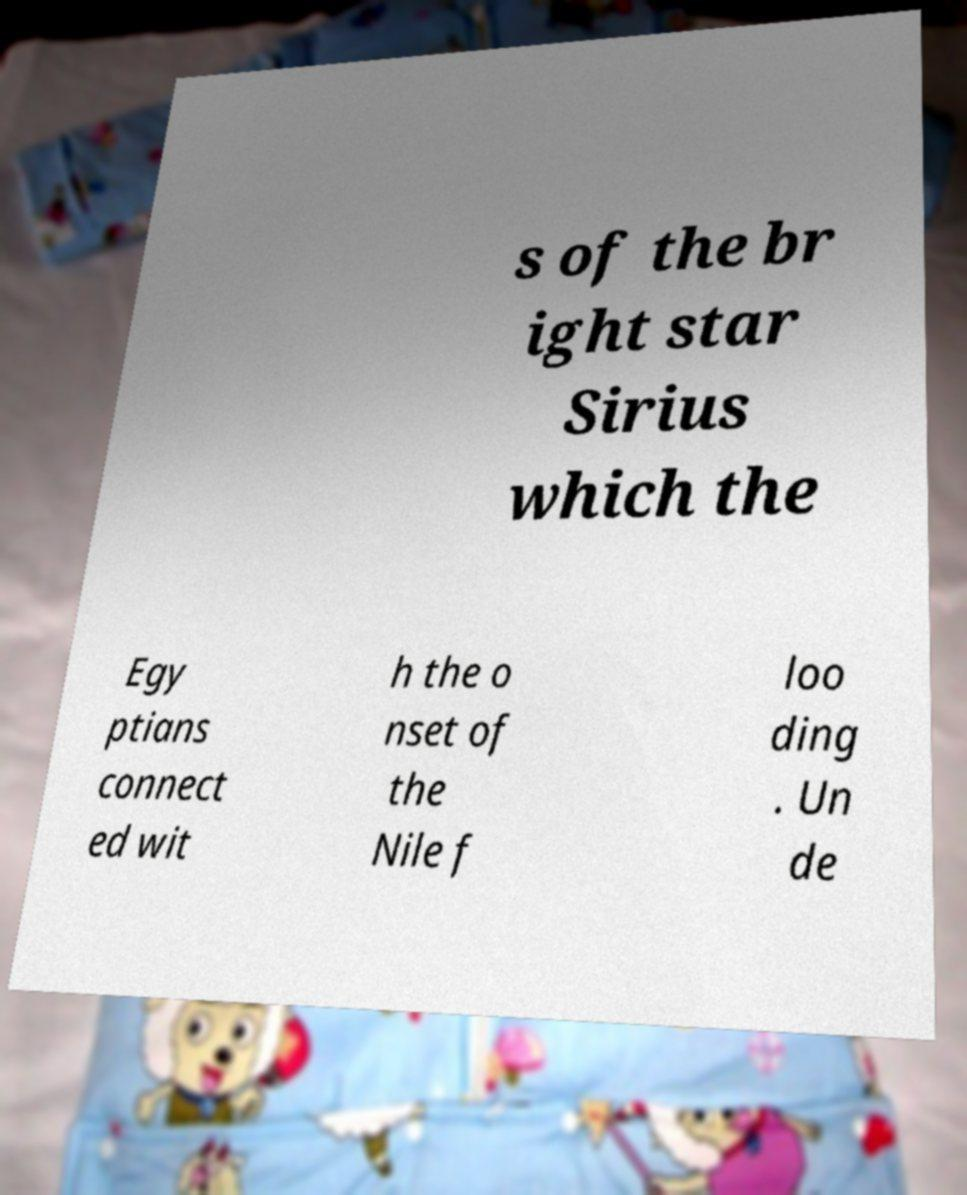What messages or text are displayed in this image? I need them in a readable, typed format. s of the br ight star Sirius which the Egy ptians connect ed wit h the o nset of the Nile f loo ding . Un de 